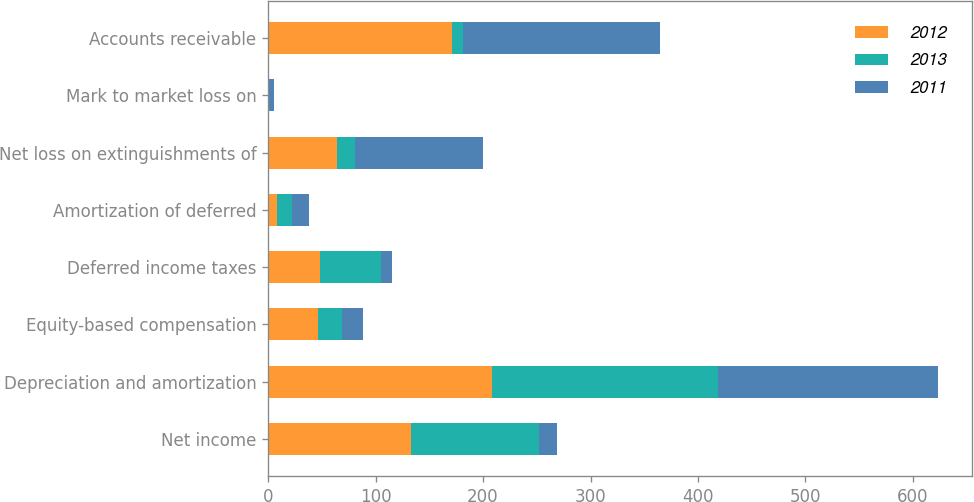Convert chart to OTSL. <chart><loc_0><loc_0><loc_500><loc_500><stacked_bar_chart><ecel><fcel>Net income<fcel>Depreciation and amortization<fcel>Equity-based compensation<fcel>Deferred income taxes<fcel>Amortization of deferred<fcel>Net loss on extinguishments of<fcel>Mark to market loss on<fcel>Accounts receivable<nl><fcel>2012<fcel>132.8<fcel>208.2<fcel>46.6<fcel>48.7<fcel>8.8<fcel>64<fcel>0.1<fcel>170.8<nl><fcel>2013<fcel>119<fcel>210.2<fcel>22.1<fcel>56.3<fcel>13.6<fcel>17.2<fcel>0.9<fcel>10.4<nl><fcel>2011<fcel>17.1<fcel>204.9<fcel>19.5<fcel>10.2<fcel>15.7<fcel>118.9<fcel>4.2<fcel>183.4<nl></chart> 